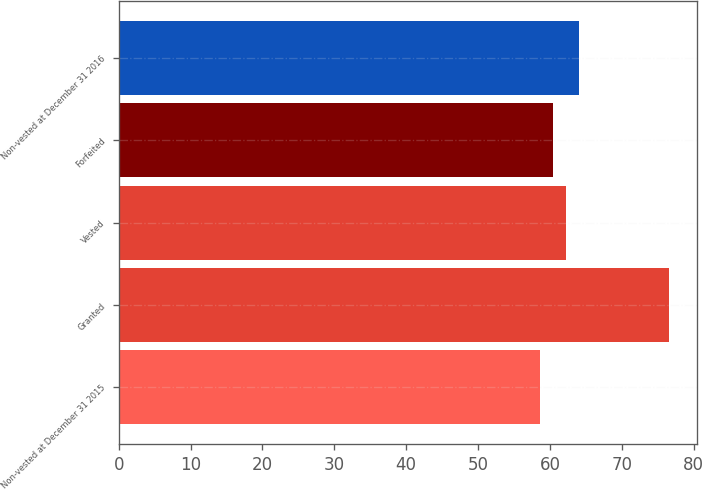<chart> <loc_0><loc_0><loc_500><loc_500><bar_chart><fcel>Non-vested at December 31 2015<fcel>Granted<fcel>Vested<fcel>Forfeited<fcel>Non-vested at December 31 2016<nl><fcel>58.56<fcel>76.62<fcel>62.18<fcel>60.37<fcel>64.04<nl></chart> 